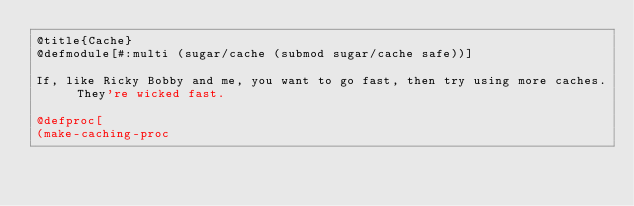<code> <loc_0><loc_0><loc_500><loc_500><_Racket_>@title{Cache}
@defmodule[#:multi (sugar/cache (submod sugar/cache safe))]

If, like Ricky Bobby and me, you want to go fast, then try using more caches. They're wicked fast.

@defproc[
(make-caching-proc</code> 